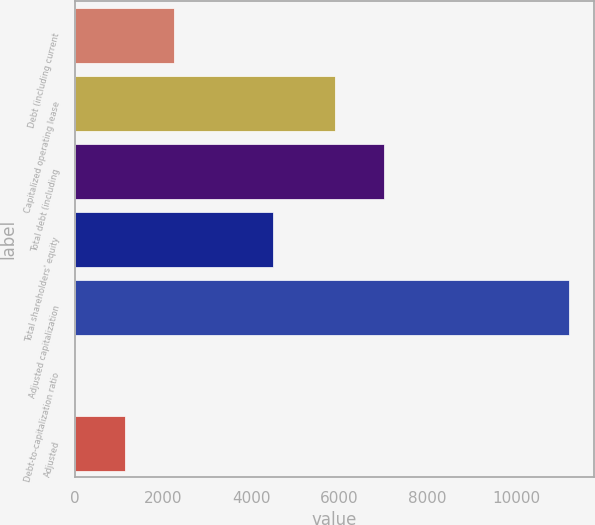Convert chart. <chart><loc_0><loc_0><loc_500><loc_500><bar_chart><fcel>Debt (including current<fcel>Capitalized operating lease<fcel>Total debt (including<fcel>Total shareholders' equity<fcel>Adjusted capitalization<fcel>Debt-to-capitalization ratio<fcel>Adjusted<nl><fcel>2252.4<fcel>5902<fcel>7020.7<fcel>4484<fcel>11202<fcel>15<fcel>1133.7<nl></chart> 